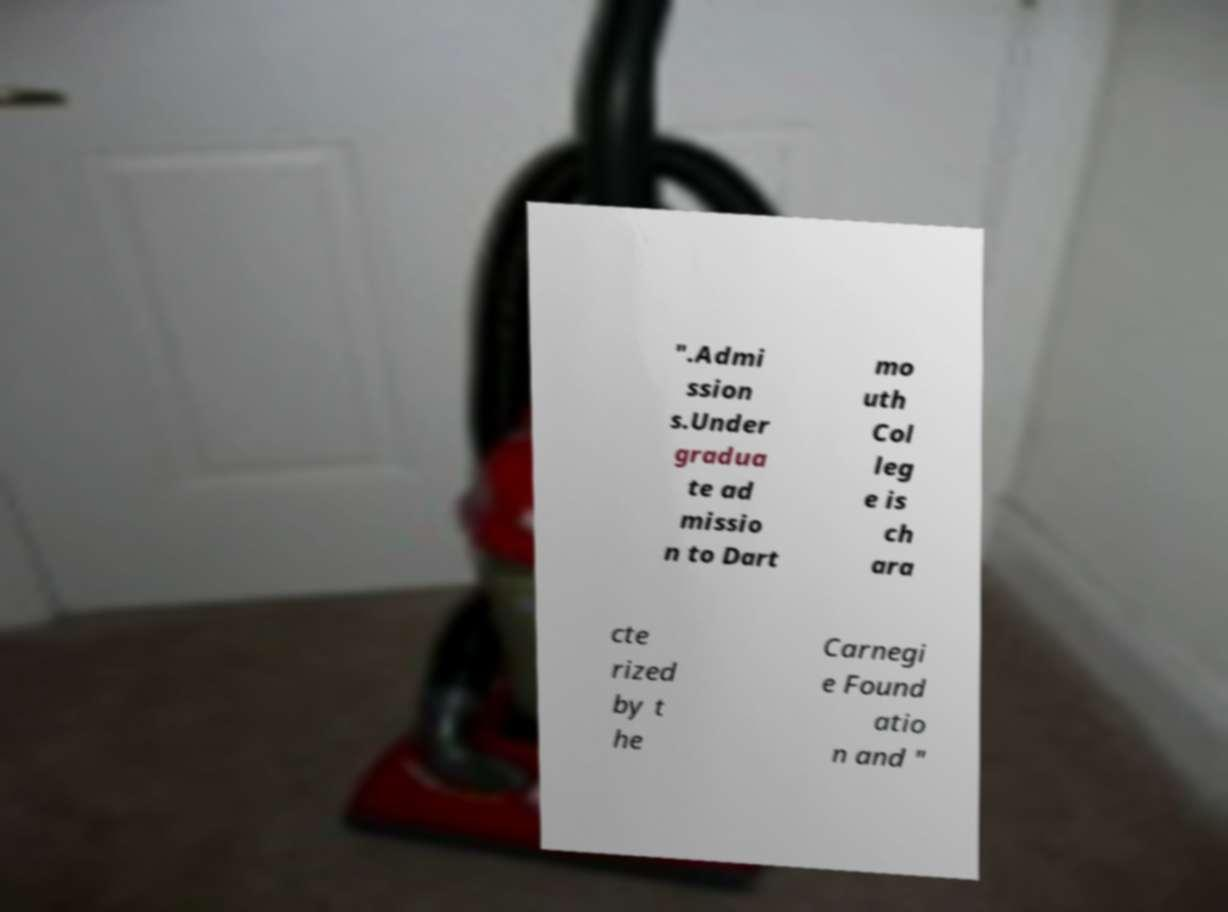Please identify and transcribe the text found in this image. ".Admi ssion s.Under gradua te ad missio n to Dart mo uth Col leg e is ch ara cte rized by t he Carnegi e Found atio n and " 